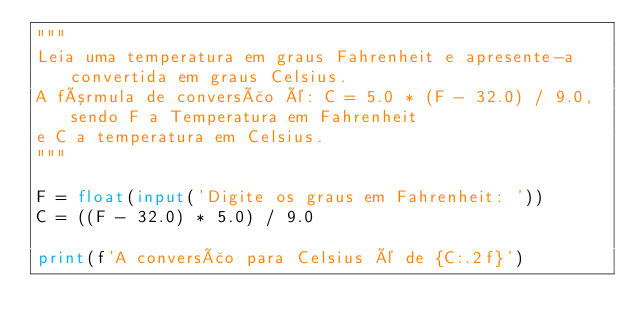<code> <loc_0><loc_0><loc_500><loc_500><_Python_>"""
Leia uma temperatura em graus Fahrenheit e apresente-a convertida em graus Celsius.
A fórmula de conversão é: C = 5.0 * (F - 32.0) / 9.0, sendo F a Temperatura em Fahrenheit
e C a temperatura em Celsius.
"""

F = float(input('Digite os graus em Fahrenheit: '))
C = ((F - 32.0) * 5.0) / 9.0

print(f'A conversão para Celsius é de {C:.2f}')
</code> 